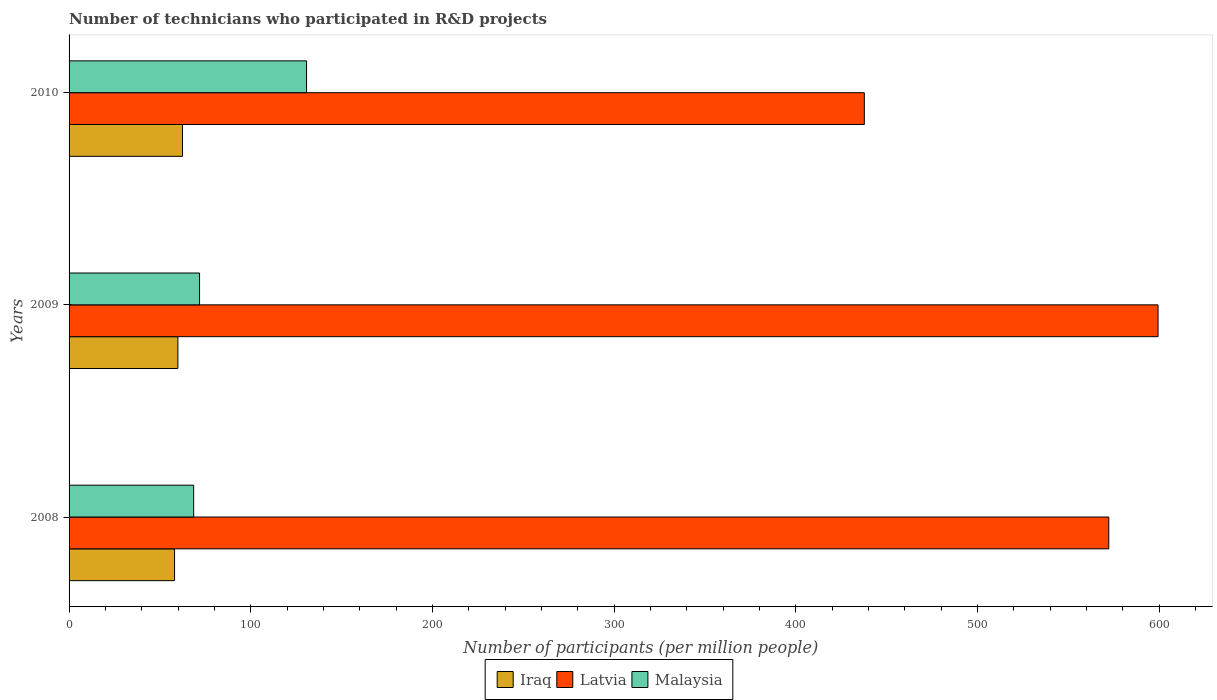How many bars are there on the 2nd tick from the top?
Your answer should be very brief. 3. How many bars are there on the 2nd tick from the bottom?
Give a very brief answer. 3. What is the label of the 3rd group of bars from the top?
Your answer should be compact. 2008. In how many cases, is the number of bars for a given year not equal to the number of legend labels?
Give a very brief answer. 0. What is the number of technicians who participated in R&D projects in Iraq in 2009?
Offer a terse response. 59.89. Across all years, what is the maximum number of technicians who participated in R&D projects in Malaysia?
Your response must be concise. 130.71. Across all years, what is the minimum number of technicians who participated in R&D projects in Latvia?
Provide a succinct answer. 437.69. In which year was the number of technicians who participated in R&D projects in Latvia maximum?
Your answer should be very brief. 2009. In which year was the number of technicians who participated in R&D projects in Iraq minimum?
Keep it short and to the point. 2008. What is the total number of technicians who participated in R&D projects in Iraq in the graph?
Your response must be concise. 180.37. What is the difference between the number of technicians who participated in R&D projects in Iraq in 2009 and that in 2010?
Ensure brevity in your answer.  -2.53. What is the difference between the number of technicians who participated in R&D projects in Iraq in 2009 and the number of technicians who participated in R&D projects in Latvia in 2008?
Ensure brevity in your answer.  -512.35. What is the average number of technicians who participated in R&D projects in Malaysia per year?
Provide a short and direct response. 90.37. In the year 2009, what is the difference between the number of technicians who participated in R&D projects in Malaysia and number of technicians who participated in R&D projects in Iraq?
Provide a succinct answer. 11.92. What is the ratio of the number of technicians who participated in R&D projects in Iraq in 2009 to that in 2010?
Keep it short and to the point. 0.96. Is the number of technicians who participated in R&D projects in Iraq in 2009 less than that in 2010?
Offer a terse response. Yes. What is the difference between the highest and the second highest number of technicians who participated in R&D projects in Latvia?
Provide a short and direct response. 27.11. What is the difference between the highest and the lowest number of technicians who participated in R&D projects in Latvia?
Give a very brief answer. 161.66. What does the 1st bar from the top in 2009 represents?
Offer a terse response. Malaysia. What does the 2nd bar from the bottom in 2010 represents?
Give a very brief answer. Latvia. Is it the case that in every year, the sum of the number of technicians who participated in R&D projects in Latvia and number of technicians who participated in R&D projects in Malaysia is greater than the number of technicians who participated in R&D projects in Iraq?
Give a very brief answer. Yes. How many bars are there?
Provide a short and direct response. 9. Are all the bars in the graph horizontal?
Make the answer very short. Yes. What is the difference between two consecutive major ticks on the X-axis?
Your answer should be very brief. 100. Does the graph contain grids?
Offer a very short reply. No. Where does the legend appear in the graph?
Your answer should be compact. Bottom center. How many legend labels are there?
Ensure brevity in your answer.  3. What is the title of the graph?
Provide a short and direct response. Number of technicians who participated in R&D projects. Does "Austria" appear as one of the legend labels in the graph?
Make the answer very short. No. What is the label or title of the X-axis?
Keep it short and to the point. Number of participants (per million people). What is the Number of participants (per million people) in Iraq in 2008?
Provide a short and direct response. 58.05. What is the Number of participants (per million people) of Latvia in 2008?
Provide a succinct answer. 572.24. What is the Number of participants (per million people) of Malaysia in 2008?
Your answer should be very brief. 68.57. What is the Number of participants (per million people) of Iraq in 2009?
Ensure brevity in your answer.  59.89. What is the Number of participants (per million people) in Latvia in 2009?
Offer a very short reply. 599.35. What is the Number of participants (per million people) in Malaysia in 2009?
Ensure brevity in your answer.  71.82. What is the Number of participants (per million people) in Iraq in 2010?
Provide a succinct answer. 62.43. What is the Number of participants (per million people) of Latvia in 2010?
Your answer should be very brief. 437.69. What is the Number of participants (per million people) of Malaysia in 2010?
Make the answer very short. 130.71. Across all years, what is the maximum Number of participants (per million people) of Iraq?
Provide a short and direct response. 62.43. Across all years, what is the maximum Number of participants (per million people) in Latvia?
Provide a short and direct response. 599.35. Across all years, what is the maximum Number of participants (per million people) in Malaysia?
Make the answer very short. 130.71. Across all years, what is the minimum Number of participants (per million people) of Iraq?
Make the answer very short. 58.05. Across all years, what is the minimum Number of participants (per million people) of Latvia?
Keep it short and to the point. 437.69. Across all years, what is the minimum Number of participants (per million people) of Malaysia?
Your response must be concise. 68.57. What is the total Number of participants (per million people) in Iraq in the graph?
Ensure brevity in your answer.  180.37. What is the total Number of participants (per million people) in Latvia in the graph?
Ensure brevity in your answer.  1609.27. What is the total Number of participants (per million people) in Malaysia in the graph?
Provide a succinct answer. 271.1. What is the difference between the Number of participants (per million people) in Iraq in 2008 and that in 2009?
Provide a succinct answer. -1.84. What is the difference between the Number of participants (per million people) of Latvia in 2008 and that in 2009?
Make the answer very short. -27.11. What is the difference between the Number of participants (per million people) in Malaysia in 2008 and that in 2009?
Make the answer very short. -3.24. What is the difference between the Number of participants (per million people) of Iraq in 2008 and that in 2010?
Your response must be concise. -4.37. What is the difference between the Number of participants (per million people) of Latvia in 2008 and that in 2010?
Offer a very short reply. 134.55. What is the difference between the Number of participants (per million people) of Malaysia in 2008 and that in 2010?
Your response must be concise. -62.14. What is the difference between the Number of participants (per million people) in Iraq in 2009 and that in 2010?
Keep it short and to the point. -2.53. What is the difference between the Number of participants (per million people) of Latvia in 2009 and that in 2010?
Offer a very short reply. 161.66. What is the difference between the Number of participants (per million people) of Malaysia in 2009 and that in 2010?
Offer a very short reply. -58.9. What is the difference between the Number of participants (per million people) of Iraq in 2008 and the Number of participants (per million people) of Latvia in 2009?
Offer a very short reply. -541.29. What is the difference between the Number of participants (per million people) in Iraq in 2008 and the Number of participants (per million people) in Malaysia in 2009?
Your response must be concise. -13.76. What is the difference between the Number of participants (per million people) of Latvia in 2008 and the Number of participants (per million people) of Malaysia in 2009?
Ensure brevity in your answer.  500.42. What is the difference between the Number of participants (per million people) of Iraq in 2008 and the Number of participants (per million people) of Latvia in 2010?
Offer a very short reply. -379.64. What is the difference between the Number of participants (per million people) in Iraq in 2008 and the Number of participants (per million people) in Malaysia in 2010?
Offer a terse response. -72.66. What is the difference between the Number of participants (per million people) of Latvia in 2008 and the Number of participants (per million people) of Malaysia in 2010?
Give a very brief answer. 441.52. What is the difference between the Number of participants (per million people) in Iraq in 2009 and the Number of participants (per million people) in Latvia in 2010?
Your answer should be compact. -377.8. What is the difference between the Number of participants (per million people) in Iraq in 2009 and the Number of participants (per million people) in Malaysia in 2010?
Ensure brevity in your answer.  -70.82. What is the difference between the Number of participants (per million people) in Latvia in 2009 and the Number of participants (per million people) in Malaysia in 2010?
Make the answer very short. 468.63. What is the average Number of participants (per million people) of Iraq per year?
Your answer should be very brief. 60.12. What is the average Number of participants (per million people) of Latvia per year?
Provide a short and direct response. 536.42. What is the average Number of participants (per million people) of Malaysia per year?
Offer a very short reply. 90.37. In the year 2008, what is the difference between the Number of participants (per million people) of Iraq and Number of participants (per million people) of Latvia?
Give a very brief answer. -514.18. In the year 2008, what is the difference between the Number of participants (per million people) in Iraq and Number of participants (per million people) in Malaysia?
Your answer should be very brief. -10.52. In the year 2008, what is the difference between the Number of participants (per million people) in Latvia and Number of participants (per million people) in Malaysia?
Ensure brevity in your answer.  503.66. In the year 2009, what is the difference between the Number of participants (per million people) in Iraq and Number of participants (per million people) in Latvia?
Offer a very short reply. -539.45. In the year 2009, what is the difference between the Number of participants (per million people) of Iraq and Number of participants (per million people) of Malaysia?
Make the answer very short. -11.92. In the year 2009, what is the difference between the Number of participants (per million people) of Latvia and Number of participants (per million people) of Malaysia?
Provide a succinct answer. 527.53. In the year 2010, what is the difference between the Number of participants (per million people) of Iraq and Number of participants (per million people) of Latvia?
Make the answer very short. -375.26. In the year 2010, what is the difference between the Number of participants (per million people) of Iraq and Number of participants (per million people) of Malaysia?
Offer a terse response. -68.29. In the year 2010, what is the difference between the Number of participants (per million people) of Latvia and Number of participants (per million people) of Malaysia?
Give a very brief answer. 306.98. What is the ratio of the Number of participants (per million people) of Iraq in 2008 to that in 2009?
Provide a succinct answer. 0.97. What is the ratio of the Number of participants (per million people) in Latvia in 2008 to that in 2009?
Offer a terse response. 0.95. What is the ratio of the Number of participants (per million people) in Malaysia in 2008 to that in 2009?
Your response must be concise. 0.95. What is the ratio of the Number of participants (per million people) in Iraq in 2008 to that in 2010?
Offer a very short reply. 0.93. What is the ratio of the Number of participants (per million people) of Latvia in 2008 to that in 2010?
Give a very brief answer. 1.31. What is the ratio of the Number of participants (per million people) in Malaysia in 2008 to that in 2010?
Provide a succinct answer. 0.52. What is the ratio of the Number of participants (per million people) of Iraq in 2009 to that in 2010?
Your answer should be compact. 0.96. What is the ratio of the Number of participants (per million people) of Latvia in 2009 to that in 2010?
Offer a very short reply. 1.37. What is the ratio of the Number of participants (per million people) in Malaysia in 2009 to that in 2010?
Make the answer very short. 0.55. What is the difference between the highest and the second highest Number of participants (per million people) in Iraq?
Your answer should be very brief. 2.53. What is the difference between the highest and the second highest Number of participants (per million people) of Latvia?
Make the answer very short. 27.11. What is the difference between the highest and the second highest Number of participants (per million people) of Malaysia?
Provide a short and direct response. 58.9. What is the difference between the highest and the lowest Number of participants (per million people) in Iraq?
Offer a very short reply. 4.37. What is the difference between the highest and the lowest Number of participants (per million people) of Latvia?
Your response must be concise. 161.66. What is the difference between the highest and the lowest Number of participants (per million people) of Malaysia?
Provide a succinct answer. 62.14. 